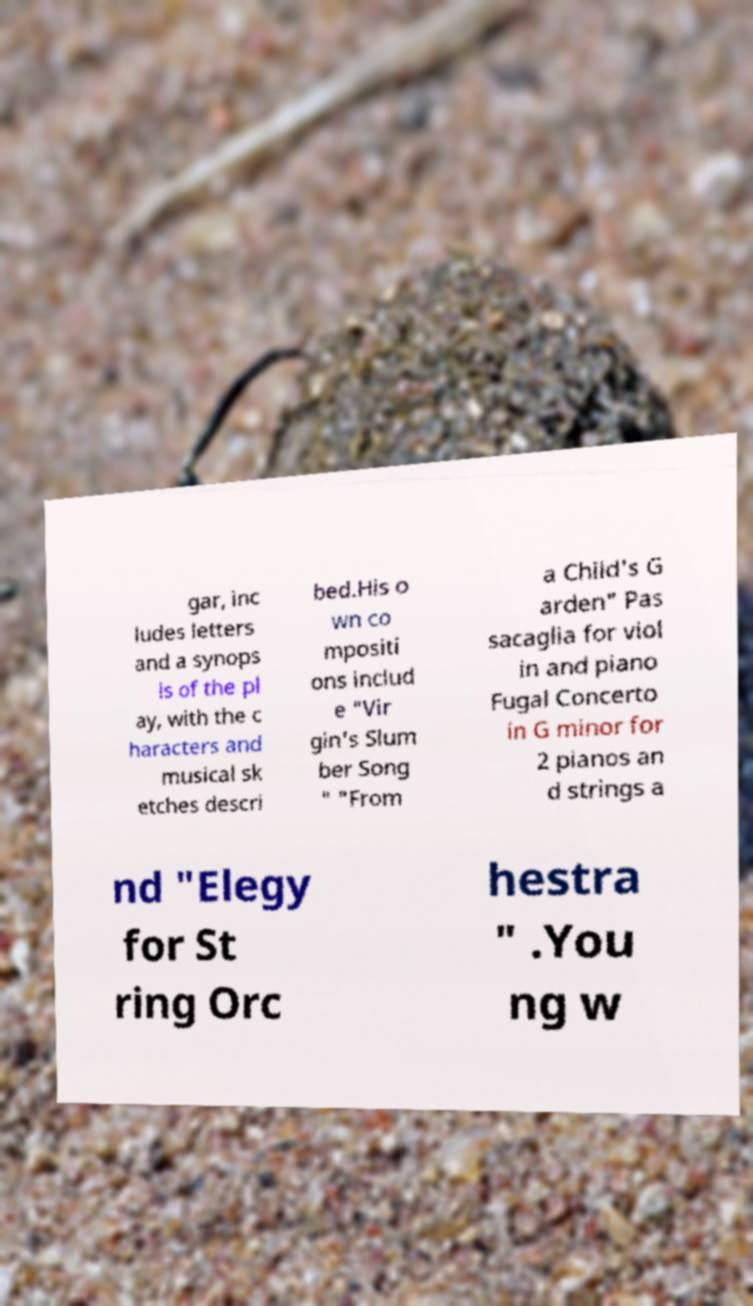Could you assist in decoding the text presented in this image and type it out clearly? gar, inc ludes letters and a synops is of the pl ay, with the c haracters and musical sk etches descri bed.His o wn co mpositi ons includ e "Vir gin's Slum ber Song " "From a Child's G arden" Pas sacaglia for viol in and piano Fugal Concerto in G minor for 2 pianos an d strings a nd "Elegy for St ring Orc hestra " .You ng w 